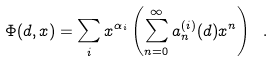<formula> <loc_0><loc_0><loc_500><loc_500>\Phi ( d , x ) = \sum _ { i } x ^ { \alpha _ { i } } \left ( \sum _ { n = 0 } ^ { \infty } a _ { n } ^ { ( i ) } ( d ) x ^ { n } \right ) \ .</formula> 